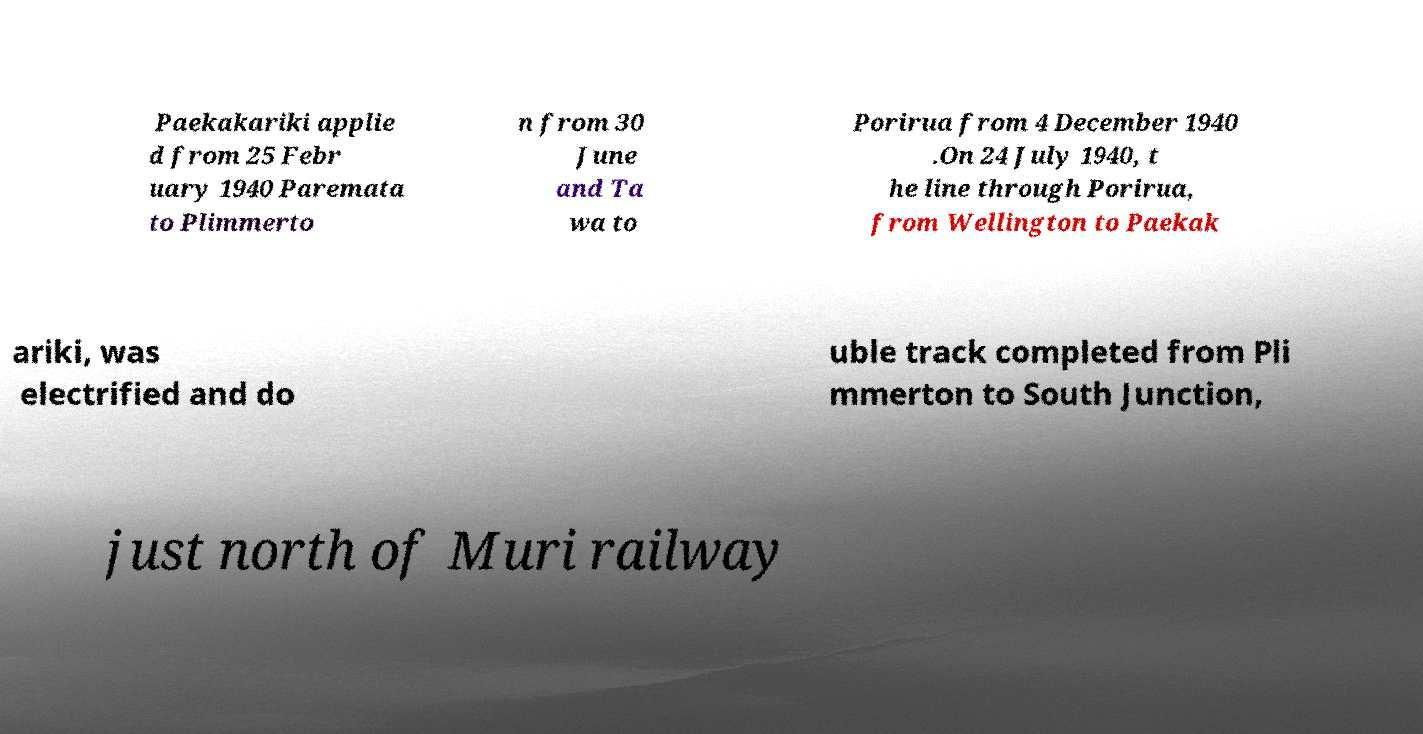What messages or text are displayed in this image? I need them in a readable, typed format. Paekakariki applie d from 25 Febr uary 1940 Paremata to Plimmerto n from 30 June and Ta wa to Porirua from 4 December 1940 .On 24 July 1940, t he line through Porirua, from Wellington to Paekak ariki, was electrified and do uble track completed from Pli mmerton to South Junction, just north of Muri railway 